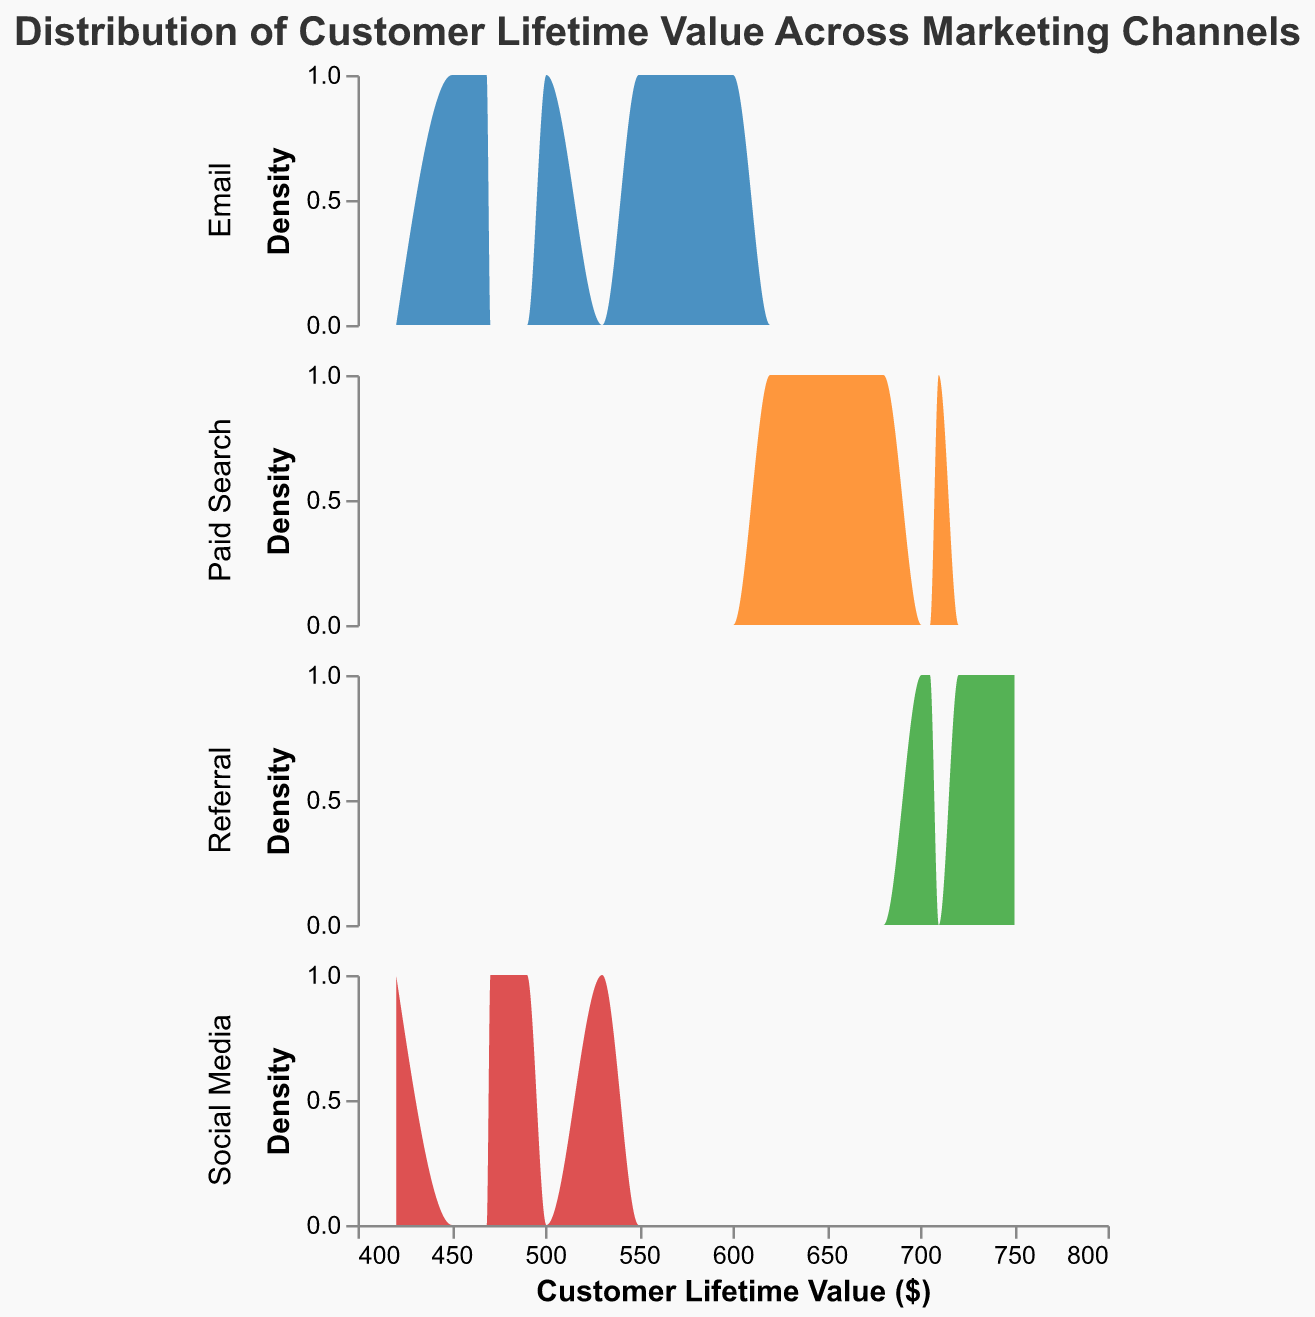What is the title of the plot? The title is usually located at the top of the plot. In this case, it reads "Distribution of Customer Lifetime Value Across Marketing Channels".
Answer: Distribution of Customer Lifetime Value Across Marketing Channels How many marketing channels are compared in this plot? By observing the different rows in the subplot, it can be seen that there are four distinct marketing channels: Email, Social Media, Paid Search, and Referral.
Answer: 4 Which marketing channel appears to have the highest overall Customer Lifetime Value? By looking at the density distribution curves, the Referral channel has the highest values overall, as its distribution is centered around higher Customer Lifetime Values compared to other channels.
Answer: Referral What is the approximate range of Customer Lifetime Values for emails? Observing the x-axis of the density plot for the Email channel, the Customer Lifetime Values range from about 450 to 600.
Answer: 450 to 600 Which marketing channel shows the widest spread in Customer Lifetime Value? The spread can be estimated by looking at the width of the distribution along the x-axis. Paid Search appears to have the widest spread, ranging approximately from 620 to 710.
Answer: Paid Search Between Email and Social Media, which channel has a higher peak density value? Comparing the height of the peaks in the Email and Social Media density plots, the Email channel appears to have a higher peak value.
Answer: Email Do any channels have overlapping Customer Lifetime Value ranges? Yes, by examining the x-axis ranges for each channel, Social Media and Email, as well as Paid Search and Referral, have overlapping Customer Lifetime Value ranges.
Answer: Yes What is the color used to represent the Paid Search channel? The Paid Search channel's color can be identified as the third color listed, which is a shade of green according to the legend.
Answer: Green For which channel does the density decline the fastest after the peak Customer Lifetime Value? Observing the decline in density after the peak for each channel, the density declines fastest for the Social Media channel.
Answer: Social Media 